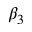Convert formula to latex. <formula><loc_0><loc_0><loc_500><loc_500>\beta _ { 3 }</formula> 